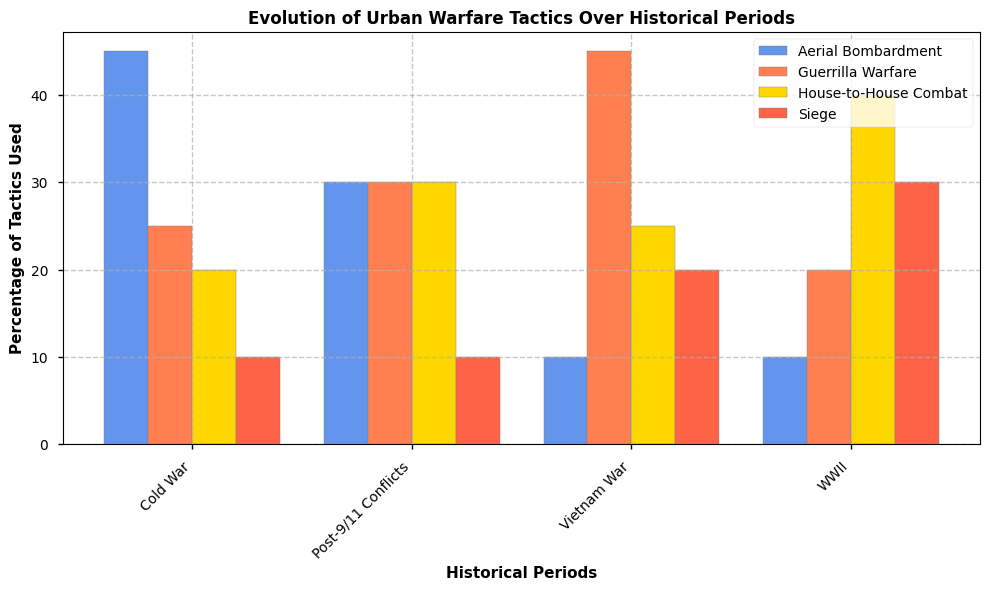Which historical period had the highest percentage of House-to-House Combat? Observe the height of the bars corresponding to House-to-House Combat across all periods. The highest bar indicates the period with the highest percentage.
Answer: WWII During which period was Guerrilla Warfare the most prominent tactic? Look at the Guerrilla Warfare bars across all periods. Identify the tallest bar as the period where Guerrilla Warfare was most prominent.
Answer: Vietnam War In which period was the use of Siege tactics least prominent? Check the heights of the Siege tactic bars for each period and find the shortest one. The period of the shortest bar indicates the least prominence.
Answer: Cold War or Post-9/11 Conflicts Compare the percentages of House-to-House Combat and Guerrilla Warfare during the Vietnam War. Which one was higher and by how much? Locate the bars for House-to-House Combat and Guerrilla Warfare in the Vietnam War period. House-to-House Combat is at 25%, Guerrilla Warfare is at 45%. Calculate the difference (45 - 25).
Answer: Guerrilla Warfare by 20% Which tactics saw an increase in usage from WWII to the Cold War? Compare the heights of the bars for each tactic in WWII and the Cold War. Identify which bars increased in height.
Answer: Aerial Bombardment What is the total percentage of all tactics used in the Post-9/11 Conflicts? Sum the percentages of all tactics in the Post-9/11 Conflicts period. 10 (Siege) + 30 (House-to-House Combat) + 30 (Guerrilla Warfare) + 30 (Aerial Bombardment) = 100%
Answer: 100% During which period does Aerial Bombardment form the largest share of tactics used? Check the heights of the Aerial Bombardment bars across all periods. The tallest bar indicates the period where it forms the largest share.
Answer: Cold War What is the average percentage of Siege tactics used across all periods? Sum the percentages of Siege tactics in all periods and divide by the number of periods. (30 + 20 + 10 + 10) / 4 = 17.5
Answer: 17.5 Which tactic saw the biggest decrease in prominence from WWII to the Vietnam War? Compare the heights of the bars for each tactic in WWII and the Vietnam War. Identify which tactic had the largest drop in bar height.
Answer: Siege How does the percentage of Aerial Bombardment change from the Cold War to the Post-9/11 Conflicts? Does it increase, decrease, or remain the same? Compare the Aerial Bombardment bars between the Cold War and the Post-9/11 Conflicts. Both bars are at 30%, thus it remains the same.
Answer: Remains the same 